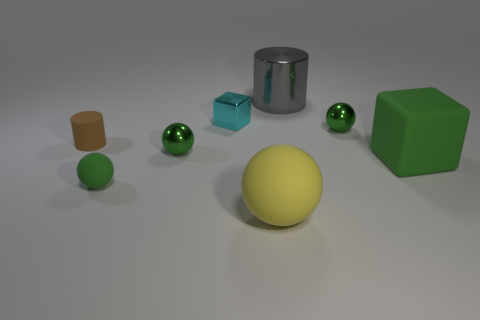Subtract all small green spheres. How many spheres are left? 1 Subtract 1 balls. How many balls are left? 3 Subtract all gray cylinders. How many cylinders are left? 1 Add 2 rubber cubes. How many objects exist? 10 Subtract all blocks. How many objects are left? 6 Subtract all large gray metallic blocks. Subtract all tiny cyan blocks. How many objects are left? 7 Add 2 small cyan shiny blocks. How many small cyan shiny blocks are left? 3 Add 4 big spheres. How many big spheres exist? 5 Subtract 0 red balls. How many objects are left? 8 Subtract all purple cylinders. Subtract all brown balls. How many cylinders are left? 2 